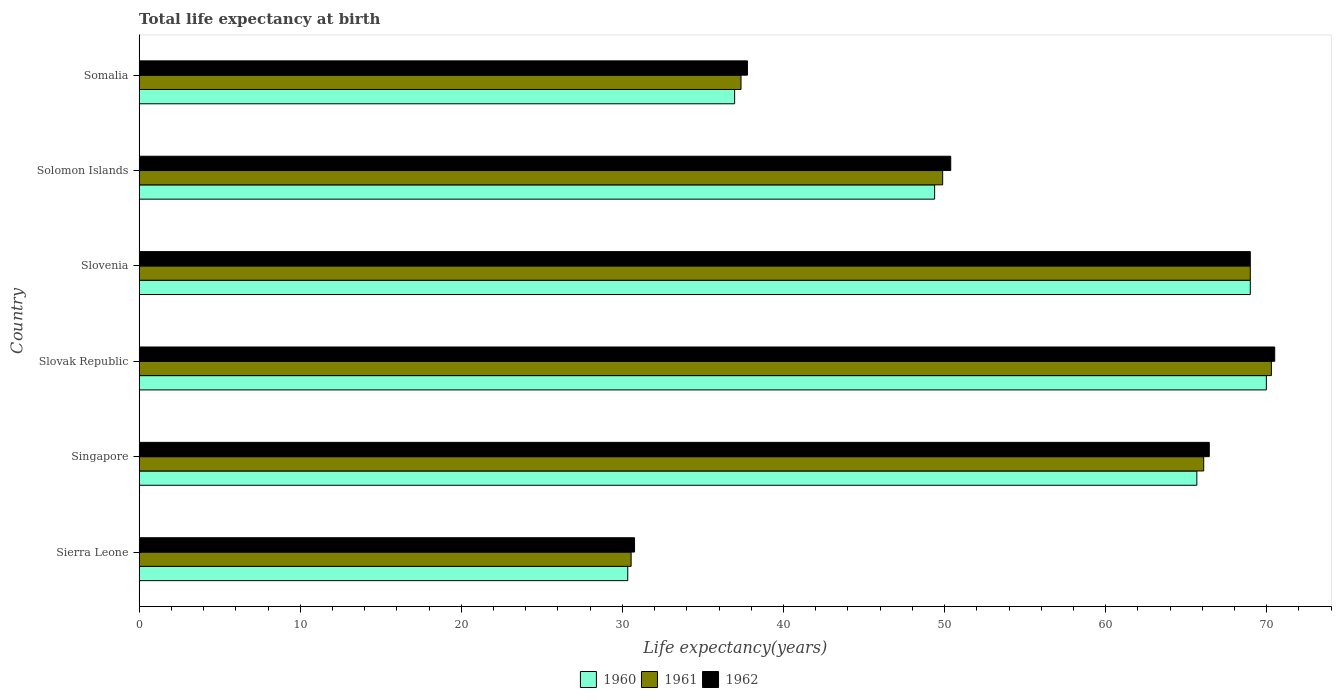How many groups of bars are there?
Your response must be concise. 6. What is the label of the 2nd group of bars from the top?
Your answer should be very brief. Solomon Islands. What is the life expectancy at birth in in 1960 in Singapore?
Make the answer very short. 65.66. Across all countries, what is the maximum life expectancy at birth in in 1961?
Give a very brief answer. 70.29. Across all countries, what is the minimum life expectancy at birth in in 1961?
Provide a short and direct response. 30.54. In which country was the life expectancy at birth in in 1961 maximum?
Provide a succinct answer. Slovak Republic. In which country was the life expectancy at birth in in 1960 minimum?
Keep it short and to the point. Sierra Leone. What is the total life expectancy at birth in in 1960 in the graph?
Keep it short and to the point. 321.29. What is the difference between the life expectancy at birth in in 1960 in Singapore and that in Somalia?
Give a very brief answer. 28.69. What is the difference between the life expectancy at birth in in 1961 in Sierra Leone and the life expectancy at birth in in 1960 in Slovenia?
Give a very brief answer. -38.44. What is the average life expectancy at birth in in 1960 per country?
Your answer should be very brief. 53.55. What is the difference between the life expectancy at birth in in 1962 and life expectancy at birth in in 1960 in Slovenia?
Offer a terse response. 0. In how many countries, is the life expectancy at birth in in 1962 greater than 48 years?
Offer a very short reply. 4. What is the ratio of the life expectancy at birth in in 1962 in Sierra Leone to that in Singapore?
Your response must be concise. 0.46. What is the difference between the highest and the second highest life expectancy at birth in in 1960?
Your answer should be very brief. 1. What is the difference between the highest and the lowest life expectancy at birth in in 1961?
Your response must be concise. 39.75. In how many countries, is the life expectancy at birth in in 1960 greater than the average life expectancy at birth in in 1960 taken over all countries?
Provide a short and direct response. 3. Is the sum of the life expectancy at birth in in 1961 in Sierra Leone and Slovenia greater than the maximum life expectancy at birth in in 1960 across all countries?
Offer a terse response. Yes. What does the 1st bar from the top in Solomon Islands represents?
Keep it short and to the point. 1962. What does the 3rd bar from the bottom in Slovak Republic represents?
Offer a terse response. 1962. How many bars are there?
Keep it short and to the point. 18. How many countries are there in the graph?
Offer a terse response. 6. What is the difference between two consecutive major ticks on the X-axis?
Make the answer very short. 10. Does the graph contain any zero values?
Your response must be concise. No. How many legend labels are there?
Give a very brief answer. 3. What is the title of the graph?
Keep it short and to the point. Total life expectancy at birth. Does "1987" appear as one of the legend labels in the graph?
Make the answer very short. No. What is the label or title of the X-axis?
Provide a short and direct response. Life expectancy(years). What is the Life expectancy(years) in 1960 in Sierra Leone?
Ensure brevity in your answer.  30.33. What is the Life expectancy(years) of 1961 in Sierra Leone?
Keep it short and to the point. 30.54. What is the Life expectancy(years) in 1962 in Sierra Leone?
Provide a succinct answer. 30.75. What is the Life expectancy(years) in 1960 in Singapore?
Provide a short and direct response. 65.66. What is the Life expectancy(years) in 1961 in Singapore?
Make the answer very short. 66.09. What is the Life expectancy(years) of 1962 in Singapore?
Offer a very short reply. 66.43. What is the Life expectancy(years) in 1960 in Slovak Republic?
Make the answer very short. 69.98. What is the Life expectancy(years) of 1961 in Slovak Republic?
Make the answer very short. 70.29. What is the Life expectancy(years) of 1962 in Slovak Republic?
Offer a very short reply. 70.49. What is the Life expectancy(years) of 1960 in Slovenia?
Give a very brief answer. 68.98. What is the Life expectancy(years) in 1961 in Slovenia?
Make the answer very short. 68.98. What is the Life expectancy(years) of 1962 in Slovenia?
Ensure brevity in your answer.  68.98. What is the Life expectancy(years) of 1960 in Solomon Islands?
Your answer should be compact. 49.38. What is the Life expectancy(years) of 1961 in Solomon Islands?
Your response must be concise. 49.88. What is the Life expectancy(years) in 1962 in Solomon Islands?
Your answer should be compact. 50.38. What is the Life expectancy(years) of 1960 in Somalia?
Make the answer very short. 36.97. What is the Life expectancy(years) of 1961 in Somalia?
Your response must be concise. 37.36. What is the Life expectancy(years) of 1962 in Somalia?
Keep it short and to the point. 37.76. Across all countries, what is the maximum Life expectancy(years) in 1960?
Provide a succinct answer. 69.98. Across all countries, what is the maximum Life expectancy(years) of 1961?
Offer a terse response. 70.29. Across all countries, what is the maximum Life expectancy(years) of 1962?
Offer a very short reply. 70.49. Across all countries, what is the minimum Life expectancy(years) in 1960?
Ensure brevity in your answer.  30.33. Across all countries, what is the minimum Life expectancy(years) in 1961?
Your response must be concise. 30.54. Across all countries, what is the minimum Life expectancy(years) in 1962?
Provide a short and direct response. 30.75. What is the total Life expectancy(years) of 1960 in the graph?
Your response must be concise. 321.29. What is the total Life expectancy(years) in 1961 in the graph?
Ensure brevity in your answer.  323.14. What is the total Life expectancy(years) of 1962 in the graph?
Give a very brief answer. 324.8. What is the difference between the Life expectancy(years) in 1960 in Sierra Leone and that in Singapore?
Keep it short and to the point. -35.33. What is the difference between the Life expectancy(years) of 1961 in Sierra Leone and that in Singapore?
Make the answer very short. -35.55. What is the difference between the Life expectancy(years) of 1962 in Sierra Leone and that in Singapore?
Keep it short and to the point. -35.68. What is the difference between the Life expectancy(years) in 1960 in Sierra Leone and that in Slovak Republic?
Provide a short and direct response. -39.64. What is the difference between the Life expectancy(years) of 1961 in Sierra Leone and that in Slovak Republic?
Your answer should be very brief. -39.75. What is the difference between the Life expectancy(years) of 1962 in Sierra Leone and that in Slovak Republic?
Offer a terse response. -39.74. What is the difference between the Life expectancy(years) of 1960 in Sierra Leone and that in Slovenia?
Keep it short and to the point. -38.65. What is the difference between the Life expectancy(years) in 1961 in Sierra Leone and that in Slovenia?
Ensure brevity in your answer.  -38.44. What is the difference between the Life expectancy(years) of 1962 in Sierra Leone and that in Slovenia?
Keep it short and to the point. -38.23. What is the difference between the Life expectancy(years) in 1960 in Sierra Leone and that in Solomon Islands?
Your response must be concise. -19.05. What is the difference between the Life expectancy(years) in 1961 in Sierra Leone and that in Solomon Islands?
Your answer should be compact. -19.34. What is the difference between the Life expectancy(years) of 1962 in Sierra Leone and that in Solomon Islands?
Offer a terse response. -19.63. What is the difference between the Life expectancy(years) in 1960 in Sierra Leone and that in Somalia?
Provide a short and direct response. -6.63. What is the difference between the Life expectancy(years) in 1961 in Sierra Leone and that in Somalia?
Provide a succinct answer. -6.82. What is the difference between the Life expectancy(years) in 1962 in Sierra Leone and that in Somalia?
Keep it short and to the point. -7.01. What is the difference between the Life expectancy(years) of 1960 in Singapore and that in Slovak Republic?
Offer a very short reply. -4.32. What is the difference between the Life expectancy(years) of 1961 in Singapore and that in Slovak Republic?
Your answer should be very brief. -4.2. What is the difference between the Life expectancy(years) in 1962 in Singapore and that in Slovak Republic?
Give a very brief answer. -4.06. What is the difference between the Life expectancy(years) of 1960 in Singapore and that in Slovenia?
Give a very brief answer. -3.32. What is the difference between the Life expectancy(years) in 1961 in Singapore and that in Slovenia?
Offer a very short reply. -2.89. What is the difference between the Life expectancy(years) in 1962 in Singapore and that in Slovenia?
Offer a very short reply. -2.55. What is the difference between the Life expectancy(years) in 1960 in Singapore and that in Solomon Islands?
Provide a short and direct response. 16.28. What is the difference between the Life expectancy(years) of 1961 in Singapore and that in Solomon Islands?
Your response must be concise. 16.21. What is the difference between the Life expectancy(years) of 1962 in Singapore and that in Solomon Islands?
Keep it short and to the point. 16.05. What is the difference between the Life expectancy(years) in 1960 in Singapore and that in Somalia?
Your answer should be very brief. 28.69. What is the difference between the Life expectancy(years) of 1961 in Singapore and that in Somalia?
Provide a succinct answer. 28.72. What is the difference between the Life expectancy(years) of 1962 in Singapore and that in Somalia?
Give a very brief answer. 28.67. What is the difference between the Life expectancy(years) in 1960 in Slovak Republic and that in Slovenia?
Give a very brief answer. 1. What is the difference between the Life expectancy(years) of 1961 in Slovak Republic and that in Slovenia?
Provide a succinct answer. 1.31. What is the difference between the Life expectancy(years) of 1962 in Slovak Republic and that in Slovenia?
Keep it short and to the point. 1.52. What is the difference between the Life expectancy(years) of 1960 in Slovak Republic and that in Solomon Islands?
Give a very brief answer. 20.59. What is the difference between the Life expectancy(years) of 1961 in Slovak Republic and that in Solomon Islands?
Offer a terse response. 20.41. What is the difference between the Life expectancy(years) of 1962 in Slovak Republic and that in Solomon Islands?
Give a very brief answer. 20.11. What is the difference between the Life expectancy(years) of 1960 in Slovak Republic and that in Somalia?
Your answer should be very brief. 33.01. What is the difference between the Life expectancy(years) of 1961 in Slovak Republic and that in Somalia?
Your answer should be compact. 32.93. What is the difference between the Life expectancy(years) of 1962 in Slovak Republic and that in Somalia?
Keep it short and to the point. 32.73. What is the difference between the Life expectancy(years) of 1960 in Slovenia and that in Solomon Islands?
Provide a short and direct response. 19.6. What is the difference between the Life expectancy(years) of 1961 in Slovenia and that in Solomon Islands?
Your answer should be very brief. 19.1. What is the difference between the Life expectancy(years) of 1962 in Slovenia and that in Solomon Islands?
Your response must be concise. 18.6. What is the difference between the Life expectancy(years) in 1960 in Slovenia and that in Somalia?
Offer a very short reply. 32.01. What is the difference between the Life expectancy(years) in 1961 in Slovenia and that in Somalia?
Provide a succinct answer. 31.62. What is the difference between the Life expectancy(years) in 1962 in Slovenia and that in Somalia?
Provide a succinct answer. 31.22. What is the difference between the Life expectancy(years) of 1960 in Solomon Islands and that in Somalia?
Provide a short and direct response. 12.42. What is the difference between the Life expectancy(years) in 1961 in Solomon Islands and that in Somalia?
Ensure brevity in your answer.  12.52. What is the difference between the Life expectancy(years) of 1962 in Solomon Islands and that in Somalia?
Offer a terse response. 12.62. What is the difference between the Life expectancy(years) of 1960 in Sierra Leone and the Life expectancy(years) of 1961 in Singapore?
Ensure brevity in your answer.  -35.76. What is the difference between the Life expectancy(years) in 1960 in Sierra Leone and the Life expectancy(years) in 1962 in Singapore?
Ensure brevity in your answer.  -36.1. What is the difference between the Life expectancy(years) in 1961 in Sierra Leone and the Life expectancy(years) in 1962 in Singapore?
Your answer should be very brief. -35.89. What is the difference between the Life expectancy(years) of 1960 in Sierra Leone and the Life expectancy(years) of 1961 in Slovak Republic?
Make the answer very short. -39.96. What is the difference between the Life expectancy(years) in 1960 in Sierra Leone and the Life expectancy(years) in 1962 in Slovak Republic?
Ensure brevity in your answer.  -40.16. What is the difference between the Life expectancy(years) of 1961 in Sierra Leone and the Life expectancy(years) of 1962 in Slovak Republic?
Make the answer very short. -39.95. What is the difference between the Life expectancy(years) of 1960 in Sierra Leone and the Life expectancy(years) of 1961 in Slovenia?
Offer a very short reply. -38.65. What is the difference between the Life expectancy(years) of 1960 in Sierra Leone and the Life expectancy(years) of 1962 in Slovenia?
Your answer should be very brief. -38.65. What is the difference between the Life expectancy(years) of 1961 in Sierra Leone and the Life expectancy(years) of 1962 in Slovenia?
Provide a short and direct response. -38.44. What is the difference between the Life expectancy(years) of 1960 in Sierra Leone and the Life expectancy(years) of 1961 in Solomon Islands?
Your answer should be compact. -19.55. What is the difference between the Life expectancy(years) of 1960 in Sierra Leone and the Life expectancy(years) of 1962 in Solomon Islands?
Your response must be concise. -20.05. What is the difference between the Life expectancy(years) of 1961 in Sierra Leone and the Life expectancy(years) of 1962 in Solomon Islands?
Your response must be concise. -19.84. What is the difference between the Life expectancy(years) of 1960 in Sierra Leone and the Life expectancy(years) of 1961 in Somalia?
Give a very brief answer. -7.03. What is the difference between the Life expectancy(years) of 1960 in Sierra Leone and the Life expectancy(years) of 1962 in Somalia?
Ensure brevity in your answer.  -7.43. What is the difference between the Life expectancy(years) of 1961 in Sierra Leone and the Life expectancy(years) of 1962 in Somalia?
Offer a terse response. -7.22. What is the difference between the Life expectancy(years) in 1960 in Singapore and the Life expectancy(years) in 1961 in Slovak Republic?
Give a very brief answer. -4.63. What is the difference between the Life expectancy(years) of 1960 in Singapore and the Life expectancy(years) of 1962 in Slovak Republic?
Offer a terse response. -4.83. What is the difference between the Life expectancy(years) of 1961 in Singapore and the Life expectancy(years) of 1962 in Slovak Republic?
Your answer should be compact. -4.41. What is the difference between the Life expectancy(years) of 1960 in Singapore and the Life expectancy(years) of 1961 in Slovenia?
Your answer should be very brief. -3.32. What is the difference between the Life expectancy(years) in 1960 in Singapore and the Life expectancy(years) in 1962 in Slovenia?
Ensure brevity in your answer.  -3.32. What is the difference between the Life expectancy(years) in 1961 in Singapore and the Life expectancy(years) in 1962 in Slovenia?
Keep it short and to the point. -2.89. What is the difference between the Life expectancy(years) of 1960 in Singapore and the Life expectancy(years) of 1961 in Solomon Islands?
Ensure brevity in your answer.  15.78. What is the difference between the Life expectancy(years) of 1960 in Singapore and the Life expectancy(years) of 1962 in Solomon Islands?
Make the answer very short. 15.28. What is the difference between the Life expectancy(years) of 1961 in Singapore and the Life expectancy(years) of 1962 in Solomon Islands?
Make the answer very short. 15.71. What is the difference between the Life expectancy(years) of 1960 in Singapore and the Life expectancy(years) of 1961 in Somalia?
Offer a very short reply. 28.3. What is the difference between the Life expectancy(years) in 1960 in Singapore and the Life expectancy(years) in 1962 in Somalia?
Provide a succinct answer. 27.9. What is the difference between the Life expectancy(years) of 1961 in Singapore and the Life expectancy(years) of 1962 in Somalia?
Provide a succinct answer. 28.33. What is the difference between the Life expectancy(years) of 1960 in Slovak Republic and the Life expectancy(years) of 1961 in Slovenia?
Keep it short and to the point. 1. What is the difference between the Life expectancy(years) in 1961 in Slovak Republic and the Life expectancy(years) in 1962 in Slovenia?
Offer a terse response. 1.31. What is the difference between the Life expectancy(years) of 1960 in Slovak Republic and the Life expectancy(years) of 1961 in Solomon Islands?
Provide a succinct answer. 20.09. What is the difference between the Life expectancy(years) in 1960 in Slovak Republic and the Life expectancy(years) in 1962 in Solomon Islands?
Make the answer very short. 19.59. What is the difference between the Life expectancy(years) of 1961 in Slovak Republic and the Life expectancy(years) of 1962 in Solomon Islands?
Offer a very short reply. 19.91. What is the difference between the Life expectancy(years) of 1960 in Slovak Republic and the Life expectancy(years) of 1961 in Somalia?
Provide a short and direct response. 32.61. What is the difference between the Life expectancy(years) in 1960 in Slovak Republic and the Life expectancy(years) in 1962 in Somalia?
Your answer should be compact. 32.21. What is the difference between the Life expectancy(years) in 1961 in Slovak Republic and the Life expectancy(years) in 1962 in Somalia?
Your answer should be very brief. 32.53. What is the difference between the Life expectancy(years) in 1960 in Slovenia and the Life expectancy(years) in 1961 in Solomon Islands?
Offer a very short reply. 19.1. What is the difference between the Life expectancy(years) of 1960 in Slovenia and the Life expectancy(years) of 1962 in Solomon Islands?
Keep it short and to the point. 18.6. What is the difference between the Life expectancy(years) in 1961 in Slovenia and the Life expectancy(years) in 1962 in Solomon Islands?
Make the answer very short. 18.6. What is the difference between the Life expectancy(years) in 1960 in Slovenia and the Life expectancy(years) in 1961 in Somalia?
Provide a short and direct response. 31.62. What is the difference between the Life expectancy(years) in 1960 in Slovenia and the Life expectancy(years) in 1962 in Somalia?
Your answer should be compact. 31.22. What is the difference between the Life expectancy(years) of 1961 in Slovenia and the Life expectancy(years) of 1962 in Somalia?
Give a very brief answer. 31.22. What is the difference between the Life expectancy(years) of 1960 in Solomon Islands and the Life expectancy(years) of 1961 in Somalia?
Offer a very short reply. 12.02. What is the difference between the Life expectancy(years) of 1960 in Solomon Islands and the Life expectancy(years) of 1962 in Somalia?
Provide a short and direct response. 11.62. What is the difference between the Life expectancy(years) of 1961 in Solomon Islands and the Life expectancy(years) of 1962 in Somalia?
Keep it short and to the point. 12.12. What is the average Life expectancy(years) of 1960 per country?
Your answer should be very brief. 53.55. What is the average Life expectancy(years) in 1961 per country?
Provide a succinct answer. 53.86. What is the average Life expectancy(years) in 1962 per country?
Provide a short and direct response. 54.13. What is the difference between the Life expectancy(years) of 1960 and Life expectancy(years) of 1961 in Sierra Leone?
Offer a terse response. -0.21. What is the difference between the Life expectancy(years) in 1960 and Life expectancy(years) in 1962 in Sierra Leone?
Your response must be concise. -0.42. What is the difference between the Life expectancy(years) of 1961 and Life expectancy(years) of 1962 in Sierra Leone?
Ensure brevity in your answer.  -0.21. What is the difference between the Life expectancy(years) of 1960 and Life expectancy(years) of 1961 in Singapore?
Offer a very short reply. -0.43. What is the difference between the Life expectancy(years) in 1960 and Life expectancy(years) in 1962 in Singapore?
Provide a succinct answer. -0.77. What is the difference between the Life expectancy(years) in 1961 and Life expectancy(years) in 1962 in Singapore?
Ensure brevity in your answer.  -0.34. What is the difference between the Life expectancy(years) in 1960 and Life expectancy(years) in 1961 in Slovak Republic?
Your response must be concise. -0.31. What is the difference between the Life expectancy(years) in 1960 and Life expectancy(years) in 1962 in Slovak Republic?
Provide a short and direct response. -0.52. What is the difference between the Life expectancy(years) in 1961 and Life expectancy(years) in 1962 in Slovak Republic?
Your answer should be compact. -0.21. What is the difference between the Life expectancy(years) in 1960 and Life expectancy(years) in 1961 in Slovenia?
Your response must be concise. 0. What is the difference between the Life expectancy(years) in 1961 and Life expectancy(years) in 1962 in Slovenia?
Offer a terse response. 0. What is the difference between the Life expectancy(years) of 1960 and Life expectancy(years) of 1961 in Solomon Islands?
Give a very brief answer. -0.5. What is the difference between the Life expectancy(years) of 1960 and Life expectancy(years) of 1962 in Solomon Islands?
Keep it short and to the point. -1. What is the difference between the Life expectancy(years) of 1961 and Life expectancy(years) of 1962 in Solomon Islands?
Provide a short and direct response. -0.5. What is the difference between the Life expectancy(years) in 1960 and Life expectancy(years) in 1961 in Somalia?
Offer a very short reply. -0.4. What is the difference between the Life expectancy(years) in 1960 and Life expectancy(years) in 1962 in Somalia?
Your answer should be compact. -0.8. What is the difference between the Life expectancy(years) in 1961 and Life expectancy(years) in 1962 in Somalia?
Keep it short and to the point. -0.4. What is the ratio of the Life expectancy(years) in 1960 in Sierra Leone to that in Singapore?
Provide a short and direct response. 0.46. What is the ratio of the Life expectancy(years) of 1961 in Sierra Leone to that in Singapore?
Ensure brevity in your answer.  0.46. What is the ratio of the Life expectancy(years) in 1962 in Sierra Leone to that in Singapore?
Provide a short and direct response. 0.46. What is the ratio of the Life expectancy(years) of 1960 in Sierra Leone to that in Slovak Republic?
Provide a succinct answer. 0.43. What is the ratio of the Life expectancy(years) in 1961 in Sierra Leone to that in Slovak Republic?
Your answer should be very brief. 0.43. What is the ratio of the Life expectancy(years) in 1962 in Sierra Leone to that in Slovak Republic?
Make the answer very short. 0.44. What is the ratio of the Life expectancy(years) in 1960 in Sierra Leone to that in Slovenia?
Offer a terse response. 0.44. What is the ratio of the Life expectancy(years) in 1961 in Sierra Leone to that in Slovenia?
Provide a succinct answer. 0.44. What is the ratio of the Life expectancy(years) of 1962 in Sierra Leone to that in Slovenia?
Provide a short and direct response. 0.45. What is the ratio of the Life expectancy(years) in 1960 in Sierra Leone to that in Solomon Islands?
Provide a short and direct response. 0.61. What is the ratio of the Life expectancy(years) of 1961 in Sierra Leone to that in Solomon Islands?
Offer a terse response. 0.61. What is the ratio of the Life expectancy(years) of 1962 in Sierra Leone to that in Solomon Islands?
Offer a terse response. 0.61. What is the ratio of the Life expectancy(years) of 1960 in Sierra Leone to that in Somalia?
Offer a very short reply. 0.82. What is the ratio of the Life expectancy(years) of 1961 in Sierra Leone to that in Somalia?
Your answer should be compact. 0.82. What is the ratio of the Life expectancy(years) in 1962 in Sierra Leone to that in Somalia?
Your answer should be very brief. 0.81. What is the ratio of the Life expectancy(years) of 1960 in Singapore to that in Slovak Republic?
Provide a succinct answer. 0.94. What is the ratio of the Life expectancy(years) in 1961 in Singapore to that in Slovak Republic?
Offer a terse response. 0.94. What is the ratio of the Life expectancy(years) in 1962 in Singapore to that in Slovak Republic?
Keep it short and to the point. 0.94. What is the ratio of the Life expectancy(years) in 1960 in Singapore to that in Slovenia?
Give a very brief answer. 0.95. What is the ratio of the Life expectancy(years) in 1961 in Singapore to that in Slovenia?
Provide a succinct answer. 0.96. What is the ratio of the Life expectancy(years) of 1962 in Singapore to that in Slovenia?
Keep it short and to the point. 0.96. What is the ratio of the Life expectancy(years) in 1960 in Singapore to that in Solomon Islands?
Your answer should be compact. 1.33. What is the ratio of the Life expectancy(years) of 1961 in Singapore to that in Solomon Islands?
Provide a short and direct response. 1.32. What is the ratio of the Life expectancy(years) in 1962 in Singapore to that in Solomon Islands?
Your answer should be very brief. 1.32. What is the ratio of the Life expectancy(years) of 1960 in Singapore to that in Somalia?
Offer a terse response. 1.78. What is the ratio of the Life expectancy(years) in 1961 in Singapore to that in Somalia?
Your answer should be very brief. 1.77. What is the ratio of the Life expectancy(years) of 1962 in Singapore to that in Somalia?
Give a very brief answer. 1.76. What is the ratio of the Life expectancy(years) in 1960 in Slovak Republic to that in Slovenia?
Ensure brevity in your answer.  1.01. What is the ratio of the Life expectancy(years) of 1960 in Slovak Republic to that in Solomon Islands?
Provide a short and direct response. 1.42. What is the ratio of the Life expectancy(years) in 1961 in Slovak Republic to that in Solomon Islands?
Your response must be concise. 1.41. What is the ratio of the Life expectancy(years) in 1962 in Slovak Republic to that in Solomon Islands?
Ensure brevity in your answer.  1.4. What is the ratio of the Life expectancy(years) in 1960 in Slovak Republic to that in Somalia?
Your response must be concise. 1.89. What is the ratio of the Life expectancy(years) of 1961 in Slovak Republic to that in Somalia?
Give a very brief answer. 1.88. What is the ratio of the Life expectancy(years) in 1962 in Slovak Republic to that in Somalia?
Give a very brief answer. 1.87. What is the ratio of the Life expectancy(years) of 1960 in Slovenia to that in Solomon Islands?
Offer a terse response. 1.4. What is the ratio of the Life expectancy(years) in 1961 in Slovenia to that in Solomon Islands?
Provide a short and direct response. 1.38. What is the ratio of the Life expectancy(years) in 1962 in Slovenia to that in Solomon Islands?
Your answer should be very brief. 1.37. What is the ratio of the Life expectancy(years) of 1960 in Slovenia to that in Somalia?
Keep it short and to the point. 1.87. What is the ratio of the Life expectancy(years) of 1961 in Slovenia to that in Somalia?
Provide a short and direct response. 1.85. What is the ratio of the Life expectancy(years) in 1962 in Slovenia to that in Somalia?
Your response must be concise. 1.83. What is the ratio of the Life expectancy(years) in 1960 in Solomon Islands to that in Somalia?
Provide a short and direct response. 1.34. What is the ratio of the Life expectancy(years) of 1961 in Solomon Islands to that in Somalia?
Your answer should be compact. 1.34. What is the ratio of the Life expectancy(years) in 1962 in Solomon Islands to that in Somalia?
Your answer should be compact. 1.33. What is the difference between the highest and the second highest Life expectancy(years) of 1960?
Offer a very short reply. 1. What is the difference between the highest and the second highest Life expectancy(years) of 1961?
Offer a very short reply. 1.31. What is the difference between the highest and the second highest Life expectancy(years) of 1962?
Ensure brevity in your answer.  1.52. What is the difference between the highest and the lowest Life expectancy(years) in 1960?
Offer a very short reply. 39.64. What is the difference between the highest and the lowest Life expectancy(years) of 1961?
Your answer should be very brief. 39.75. What is the difference between the highest and the lowest Life expectancy(years) in 1962?
Keep it short and to the point. 39.74. 